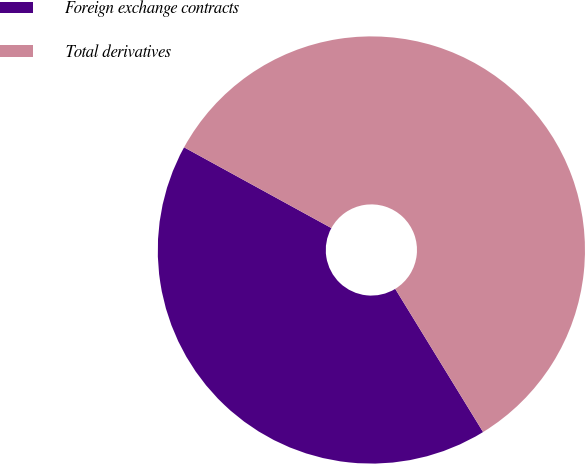Convert chart. <chart><loc_0><loc_0><loc_500><loc_500><pie_chart><fcel>Foreign exchange contracts<fcel>Total derivatives<nl><fcel>41.74%<fcel>58.26%<nl></chart> 